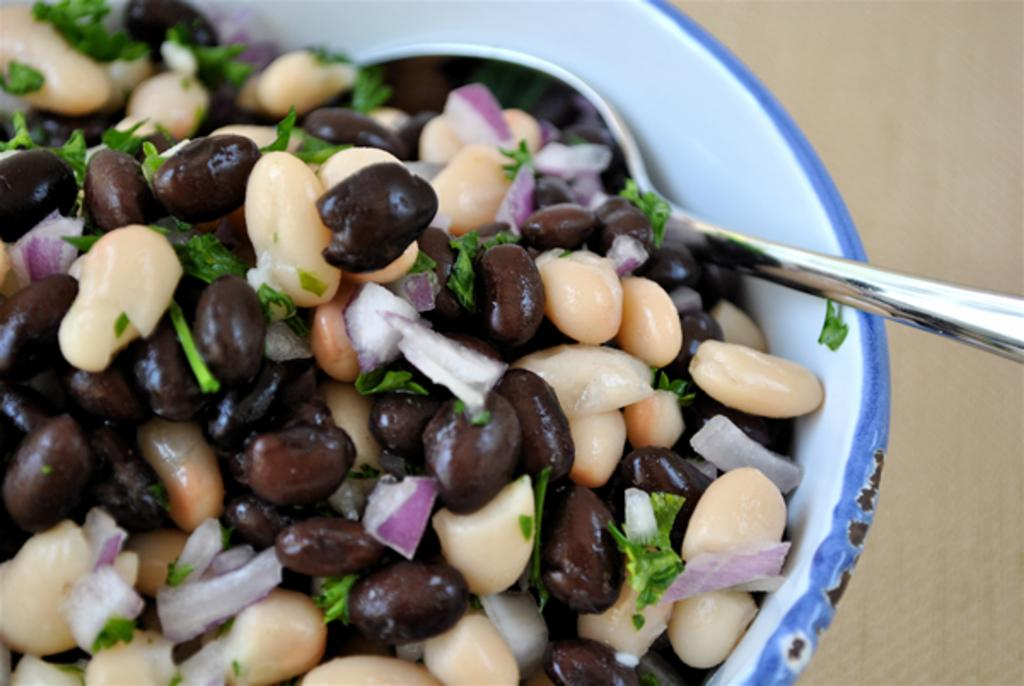What is in the bowl that is visible in the image? There is a bowl with food in the image. What utensil is present in the image? There is a spoon in the image. Where is the bowl and spoon located? The bowl and spoon are on an object that looks like a table. Can you tell me how many shoes are visible in the image? There are no shoes present in the image. What type of box is located on the table in the image? There is no box present on the table in the image. 